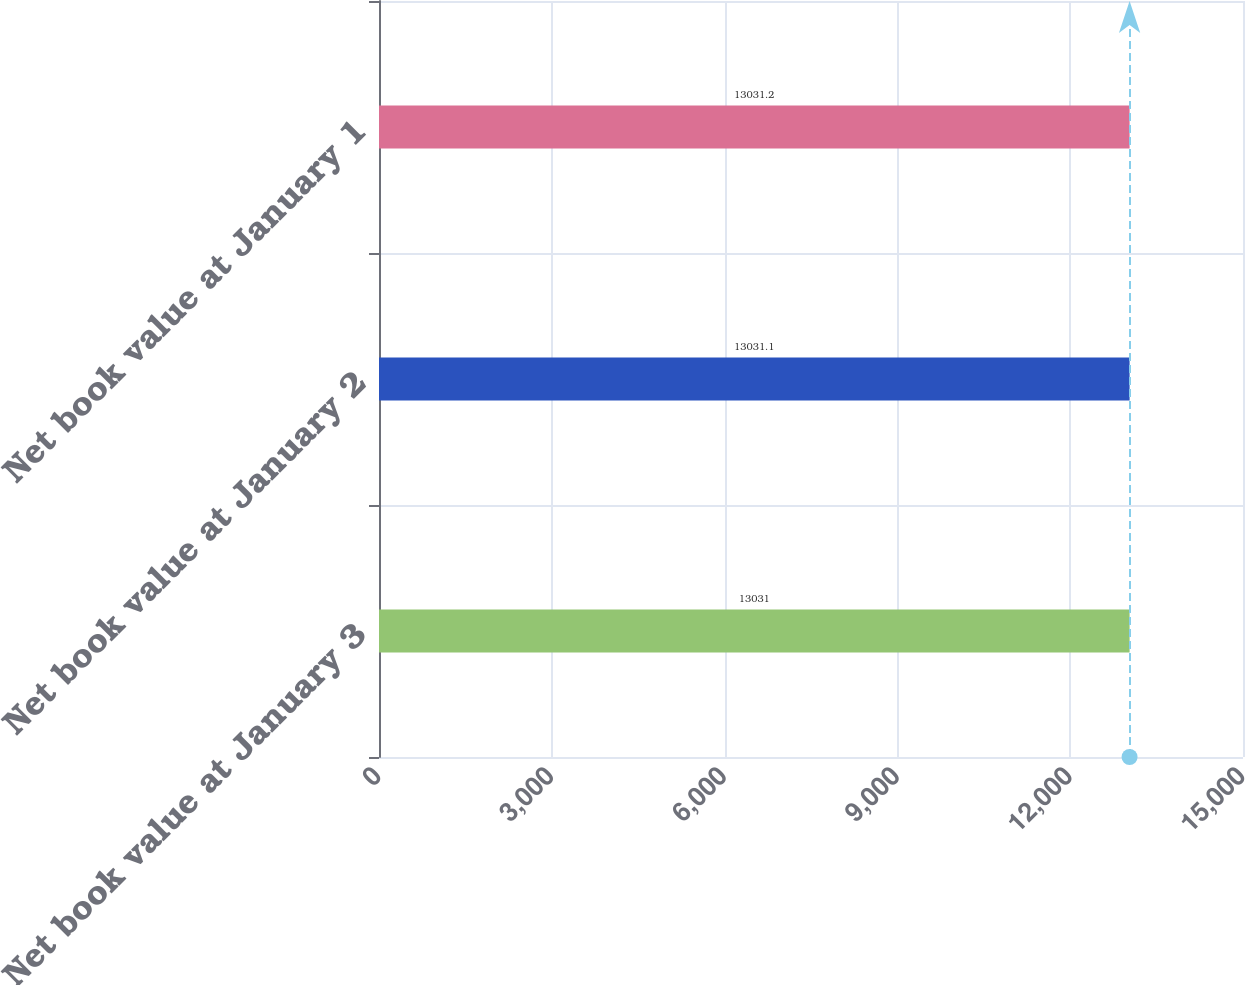<chart> <loc_0><loc_0><loc_500><loc_500><bar_chart><fcel>Net book value at January 3<fcel>Net book value at January 2<fcel>Net book value at January 1<nl><fcel>13031<fcel>13031.1<fcel>13031.2<nl></chart> 